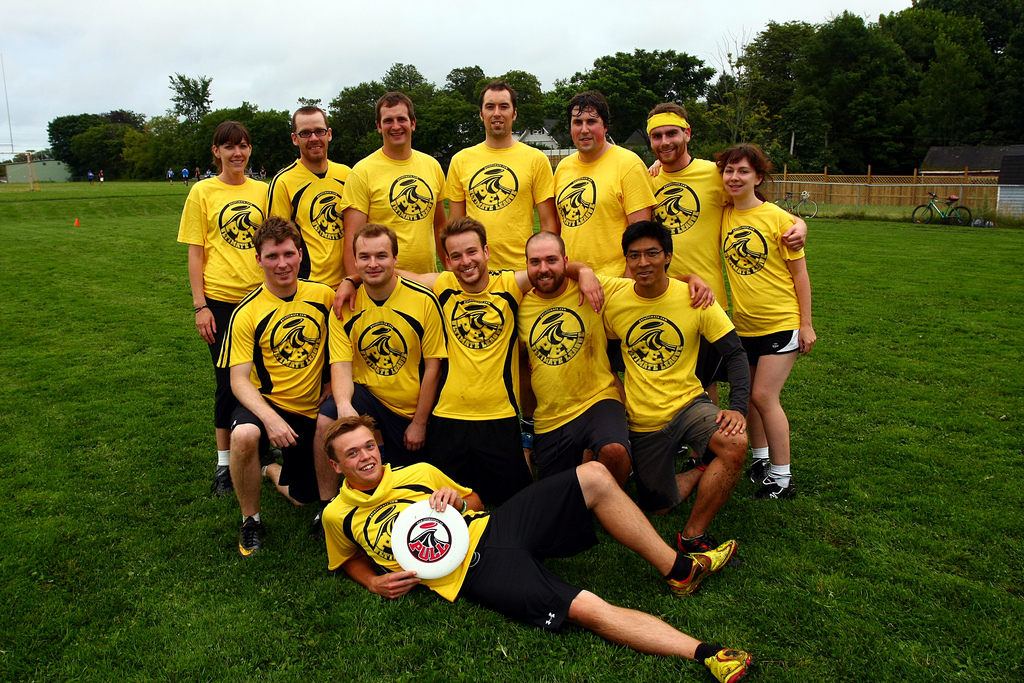How many people are lying down? 1 